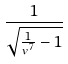<formula> <loc_0><loc_0><loc_500><loc_500>\frac { 1 } { \sqrt { \frac { 1 } { v ^ { 7 } } - 1 } }</formula> 